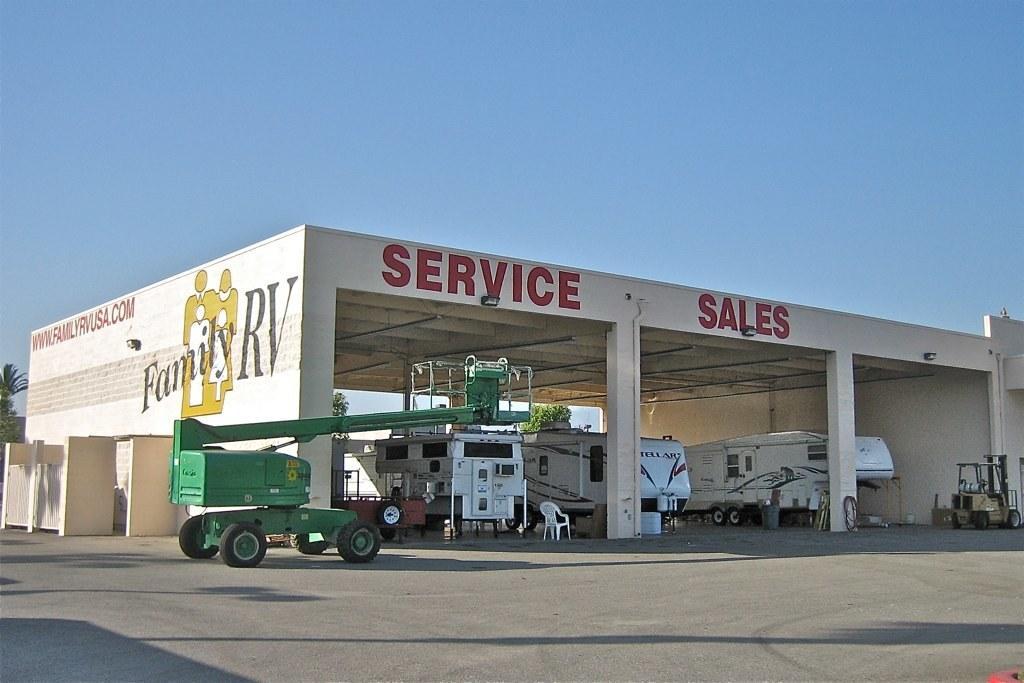Can you describe this image briefly? In this image there is the sky, there is a service station, there are vehicles, there is a chair, there is text on the wall, there are trees truncated towards the left of the image, there is a road. 